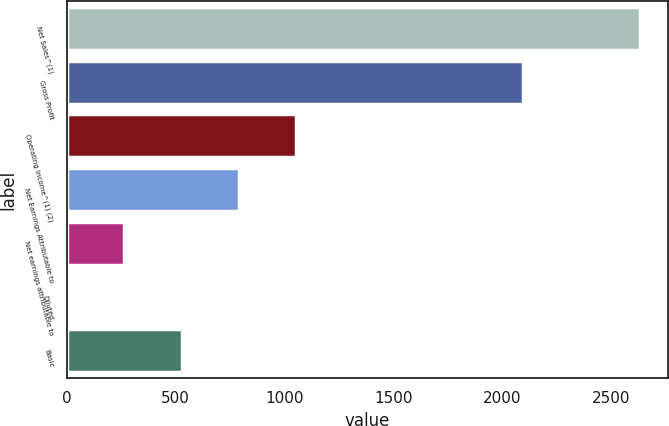Convert chart to OTSL. <chart><loc_0><loc_0><loc_500><loc_500><bar_chart><fcel>Net Sales^(1)<fcel>Gross Profit<fcel>Operating Income^(1) (2)<fcel>Net Earnings Attributable to<fcel>Net earnings attributable to<fcel>Diluted<fcel>Basic<nl><fcel>2631<fcel>2094.4<fcel>1052.75<fcel>789.71<fcel>263.63<fcel>0.59<fcel>526.67<nl></chart> 